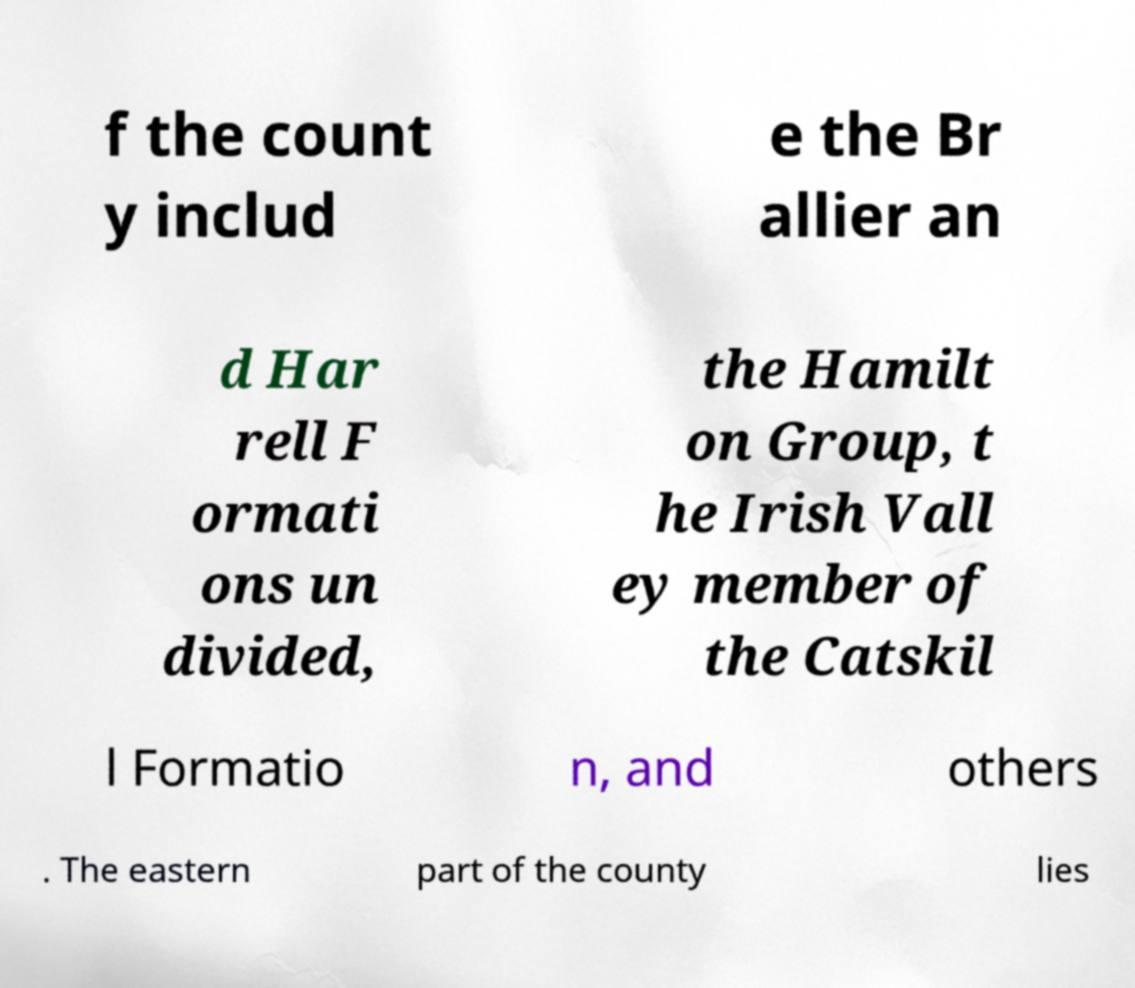I need the written content from this picture converted into text. Can you do that? f the count y includ e the Br allier an d Har rell F ormati ons un divided, the Hamilt on Group, t he Irish Vall ey member of the Catskil l Formatio n, and others . The eastern part of the county lies 